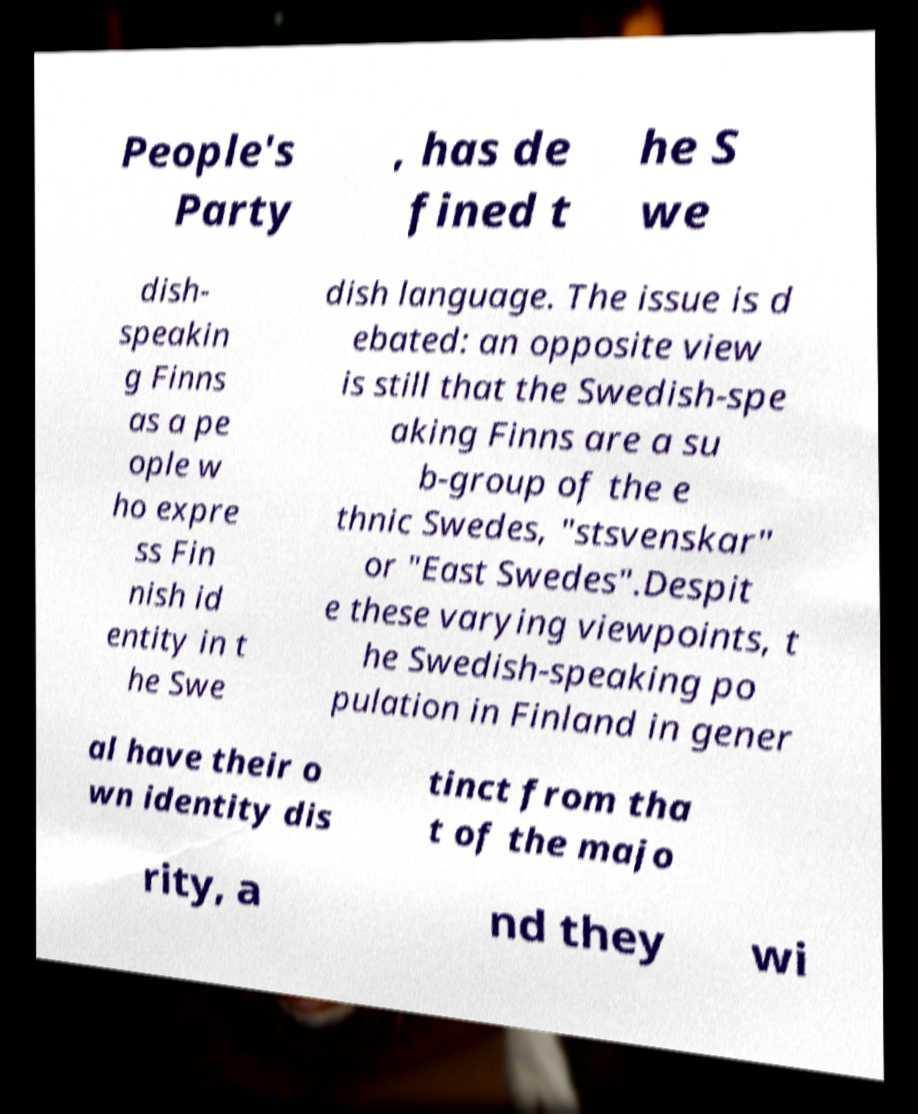Can you read and provide the text displayed in the image?This photo seems to have some interesting text. Can you extract and type it out for me? People's Party , has de fined t he S we dish- speakin g Finns as a pe ople w ho expre ss Fin nish id entity in t he Swe dish language. The issue is d ebated: an opposite view is still that the Swedish-spe aking Finns are a su b-group of the e thnic Swedes, "stsvenskar" or "East Swedes".Despit e these varying viewpoints, t he Swedish-speaking po pulation in Finland in gener al have their o wn identity dis tinct from tha t of the majo rity, a nd they wi 